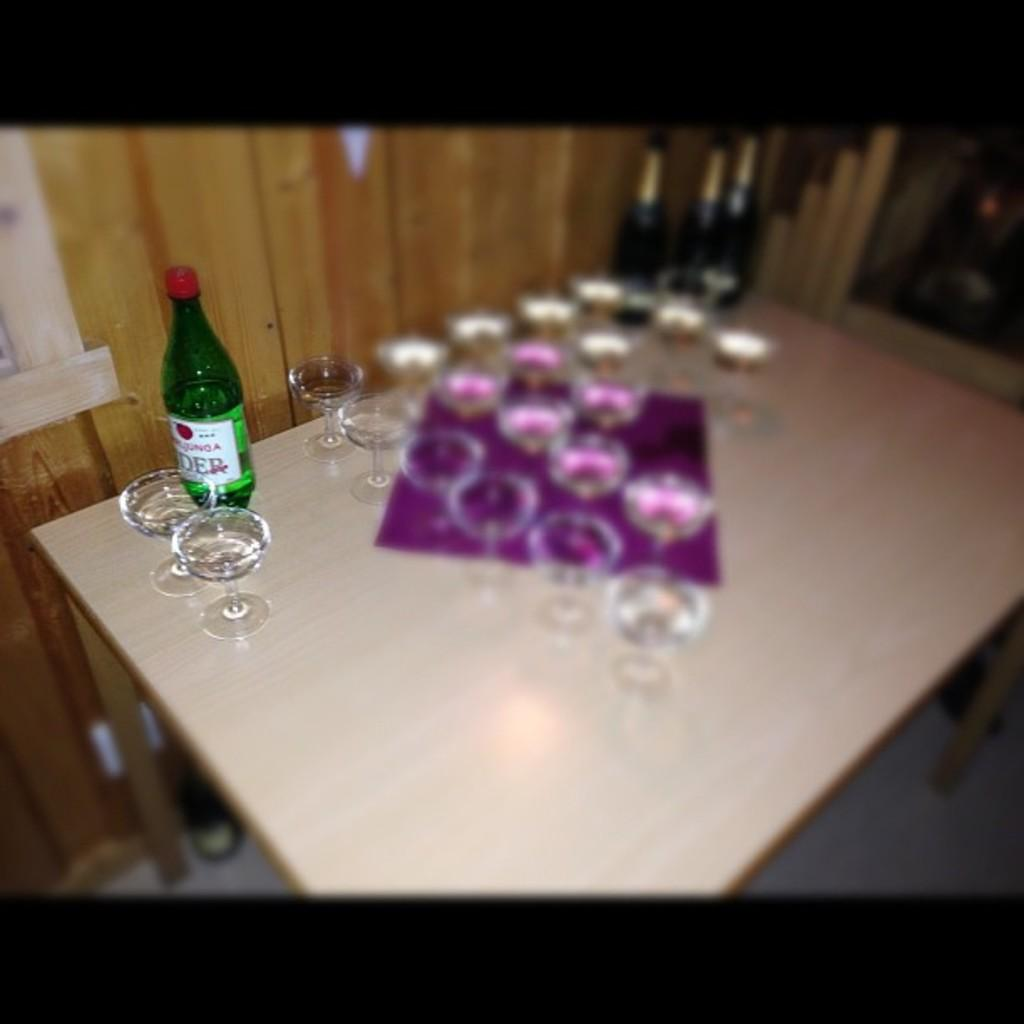What piece of furniture is present in the image? There is a table in the image. What items are placed on the table? There are glasses and a bottle on the table. What color is the cloth on the table? The cloth on the table is pink. What can be seen in the background of the image? There is a wall visible in the background of the image. What level of expertise does the beginner have with the wine in the image? There is no wine present in the image, so it is not possible to determine the level of expertise of a beginner. What type of furniture is used for writing or studying in the image? There is no desk present in the image, so it is not possible to determine what type of furniture is used for writing or studying. 